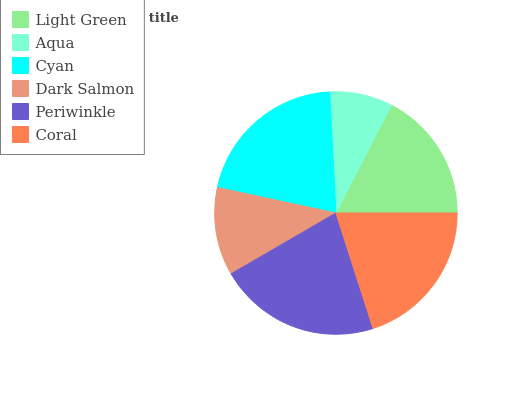Is Aqua the minimum?
Answer yes or no. Yes. Is Periwinkle the maximum?
Answer yes or no. Yes. Is Cyan the minimum?
Answer yes or no. No. Is Cyan the maximum?
Answer yes or no. No. Is Cyan greater than Aqua?
Answer yes or no. Yes. Is Aqua less than Cyan?
Answer yes or no. Yes. Is Aqua greater than Cyan?
Answer yes or no. No. Is Cyan less than Aqua?
Answer yes or no. No. Is Coral the high median?
Answer yes or no. Yes. Is Light Green the low median?
Answer yes or no. Yes. Is Light Green the high median?
Answer yes or no. No. Is Coral the low median?
Answer yes or no. No. 